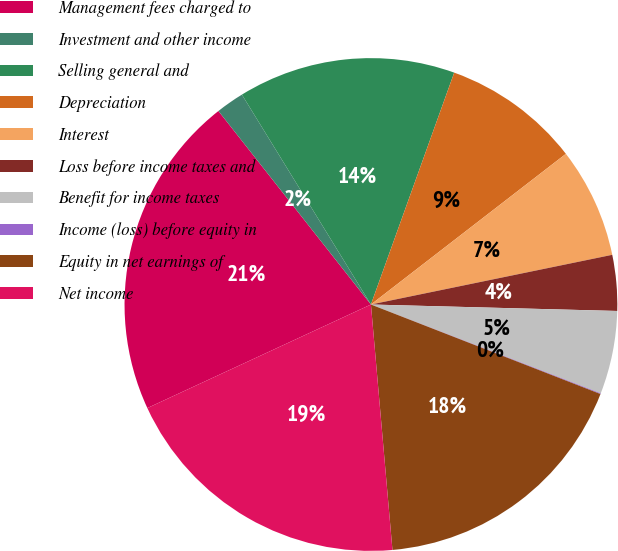<chart> <loc_0><loc_0><loc_500><loc_500><pie_chart><fcel>Management fees charged to<fcel>Investment and other income<fcel>Selling general and<fcel>Depreciation<fcel>Interest<fcel>Loss before income taxes and<fcel>Benefit for income taxes<fcel>Income (loss) before equity in<fcel>Equity in net earnings of<fcel>Net income<nl><fcel>21.28%<fcel>1.85%<fcel>14.26%<fcel>9.04%<fcel>7.24%<fcel>3.65%<fcel>5.45%<fcel>0.05%<fcel>17.69%<fcel>19.49%<nl></chart> 